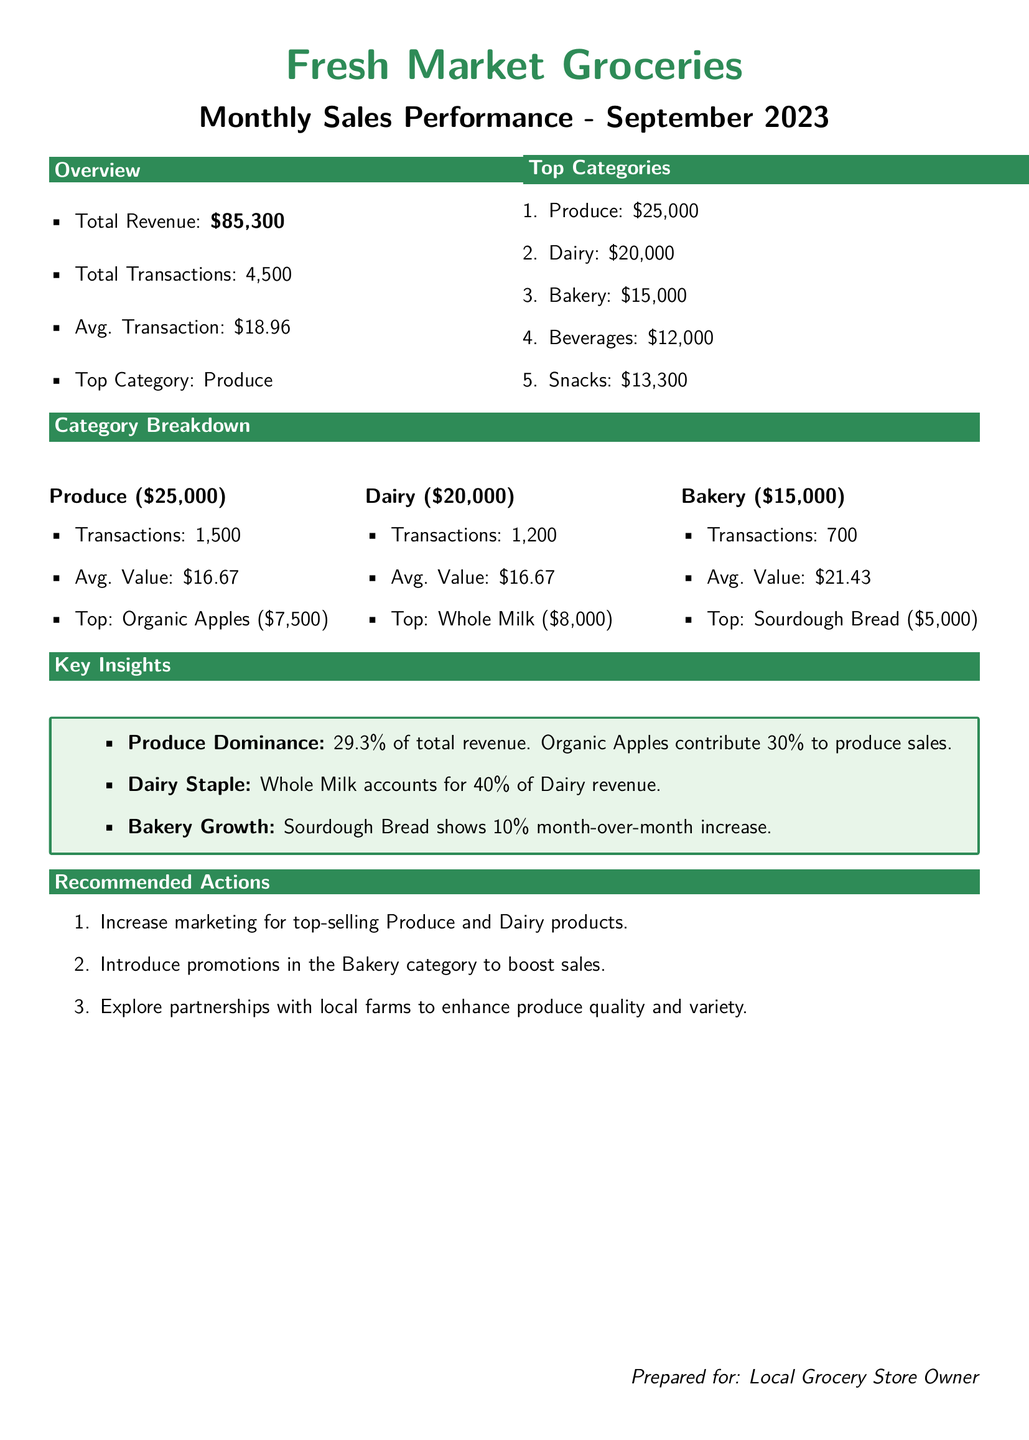what is the total revenue? The total revenue is the sum of all revenues listed in the document, which is $25,000 + $20,000 + $15,000 + $12,000 + $13,300.
Answer: $85,300 what is the top-selling category? The document explicitly states the top category based on sales for the month.
Answer: Produce how many average transactions were there? The average transaction is calculated from total revenue divided by total transactions.
Answer: $18.96 which product contributed to the highest sales in Produce? The document identifies the top product in the Produce category.
Answer: Organic Apples what percentage of total revenue does Produce represent? The document provides specific revenue amounts, allowing for the calculation of percentage from Produce sales.
Answer: 29.3% what is the average transaction value for Dairy? The average transaction value is noted as the same for both Dairy and Produce, indicating comparable sales patterns.
Answer: $16.67 how many total transactions were made in September 2023? The total transactions are listed as part of the overall performance metrics.
Answer: 4,500 which category showed a month-over-month increase? This specific detail is highlighted in the Key Insights section, informing about growth trends.
Answer: Bakery what is the revenue from Dairy products? The document specifies the total revenue generated from the Dairy category.
Answer: $20,000 